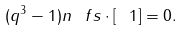<formula> <loc_0><loc_0><loc_500><loc_500>( q ^ { 3 } - 1 ) n _ { \ } f s \cdot [ \ 1 ] = 0 .</formula> 